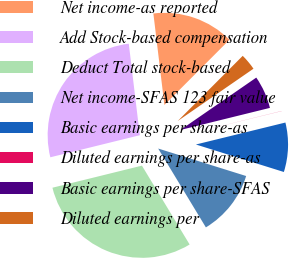Convert chart to OTSL. <chart><loc_0><loc_0><loc_500><loc_500><pie_chart><fcel>Net income-as reported<fcel>Add Stock-based compensation<fcel>Deduct Total stock-based<fcel>Net income-SFAS 123 fair value<fcel>Basic earnings per share-as<fcel>Diluted earnings per share-as<fcel>Basic earnings per share-SFAS<fcel>Diluted earnings per<nl><fcel>14.39%<fcel>26.94%<fcel>29.81%<fcel>11.52%<fcel>8.65%<fcel>0.02%<fcel>5.77%<fcel>2.9%<nl></chart> 